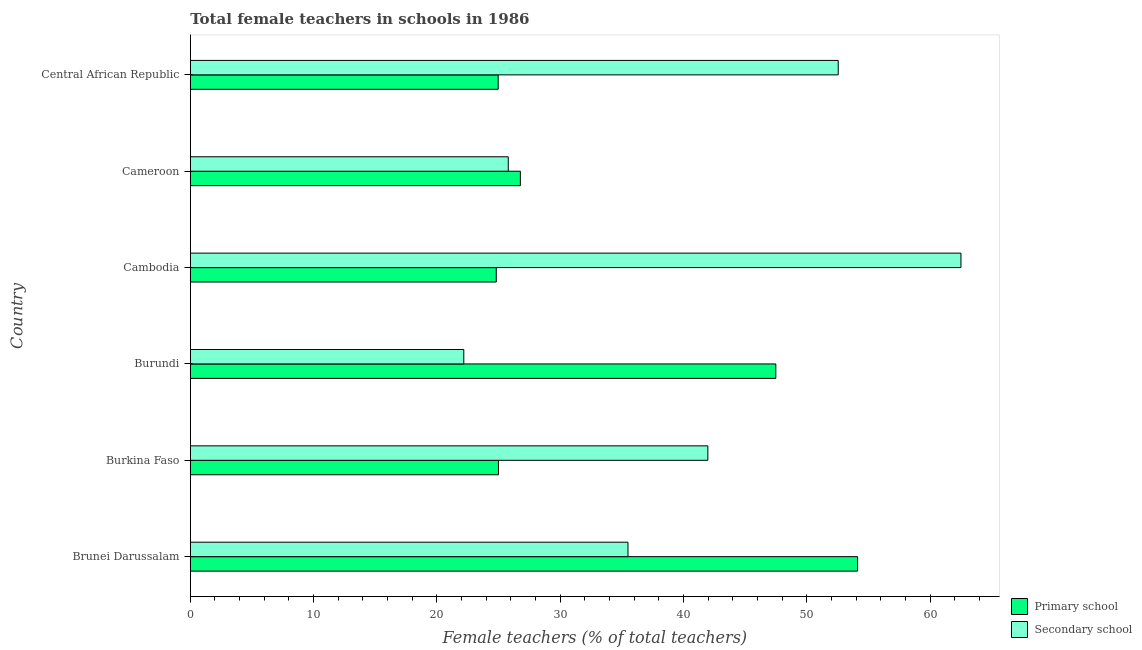How many groups of bars are there?
Give a very brief answer. 6. Are the number of bars on each tick of the Y-axis equal?
Ensure brevity in your answer.  Yes. How many bars are there on the 6th tick from the top?
Provide a succinct answer. 2. How many bars are there on the 2nd tick from the bottom?
Offer a very short reply. 2. What is the label of the 6th group of bars from the top?
Your answer should be compact. Brunei Darussalam. In how many cases, is the number of bars for a given country not equal to the number of legend labels?
Give a very brief answer. 0. What is the percentage of female teachers in primary schools in Brunei Darussalam?
Give a very brief answer. 54.11. Across all countries, what is the maximum percentage of female teachers in primary schools?
Offer a terse response. 54.11. Across all countries, what is the minimum percentage of female teachers in primary schools?
Offer a terse response. 24.81. In which country was the percentage of female teachers in secondary schools maximum?
Ensure brevity in your answer.  Cambodia. In which country was the percentage of female teachers in primary schools minimum?
Offer a terse response. Cambodia. What is the total percentage of female teachers in secondary schools in the graph?
Keep it short and to the point. 240.46. What is the difference between the percentage of female teachers in primary schools in Brunei Darussalam and that in Burundi?
Provide a succinct answer. 6.63. What is the difference between the percentage of female teachers in primary schools in Cameroon and the percentage of female teachers in secondary schools in Burkina Faso?
Provide a short and direct response. -15.2. What is the average percentage of female teachers in primary schools per country?
Give a very brief answer. 33.85. What is the difference between the percentage of female teachers in primary schools and percentage of female teachers in secondary schools in Central African Republic?
Keep it short and to the point. -27.57. What is the ratio of the percentage of female teachers in primary schools in Burundi to that in Cambodia?
Your answer should be very brief. 1.91. Is the percentage of female teachers in secondary schools in Brunei Darussalam less than that in Burundi?
Your answer should be compact. No. Is the difference between the percentage of female teachers in primary schools in Cambodia and Central African Republic greater than the difference between the percentage of female teachers in secondary schools in Cambodia and Central African Republic?
Provide a short and direct response. No. What is the difference between the highest and the second highest percentage of female teachers in secondary schools?
Offer a terse response. 9.95. What is the difference between the highest and the lowest percentage of female teachers in primary schools?
Your response must be concise. 29.3. In how many countries, is the percentage of female teachers in primary schools greater than the average percentage of female teachers in primary schools taken over all countries?
Keep it short and to the point. 2. Is the sum of the percentage of female teachers in secondary schools in Burkina Faso and Central African Republic greater than the maximum percentage of female teachers in primary schools across all countries?
Make the answer very short. Yes. What does the 1st bar from the top in Cameroon represents?
Offer a very short reply. Secondary school. What does the 1st bar from the bottom in Central African Republic represents?
Give a very brief answer. Primary school. How many bars are there?
Give a very brief answer. 12. Are all the bars in the graph horizontal?
Provide a succinct answer. Yes. What is the difference between two consecutive major ticks on the X-axis?
Keep it short and to the point. 10. Are the values on the major ticks of X-axis written in scientific E-notation?
Keep it short and to the point. No. Does the graph contain any zero values?
Offer a terse response. No. Where does the legend appear in the graph?
Ensure brevity in your answer.  Bottom right. How many legend labels are there?
Your answer should be compact. 2. What is the title of the graph?
Give a very brief answer. Total female teachers in schools in 1986. Does "Tetanus" appear as one of the legend labels in the graph?
Offer a very short reply. No. What is the label or title of the X-axis?
Ensure brevity in your answer.  Female teachers (% of total teachers). What is the label or title of the Y-axis?
Your answer should be very brief. Country. What is the Female teachers (% of total teachers) of Primary school in Brunei Darussalam?
Your response must be concise. 54.11. What is the Female teachers (% of total teachers) of Secondary school in Brunei Darussalam?
Make the answer very short. 35.49. What is the Female teachers (% of total teachers) of Primary school in Burkina Faso?
Your response must be concise. 24.99. What is the Female teachers (% of total teachers) in Secondary school in Burkina Faso?
Make the answer very short. 41.97. What is the Female teachers (% of total teachers) of Primary school in Burundi?
Provide a short and direct response. 47.48. What is the Female teachers (% of total teachers) in Secondary school in Burundi?
Offer a terse response. 22.18. What is the Female teachers (% of total teachers) of Primary school in Cambodia?
Ensure brevity in your answer.  24.81. What is the Female teachers (% of total teachers) in Secondary school in Cambodia?
Offer a terse response. 62.49. What is the Female teachers (% of total teachers) in Primary school in Cameroon?
Offer a very short reply. 26.77. What is the Female teachers (% of total teachers) in Secondary school in Cameroon?
Offer a terse response. 25.78. What is the Female teachers (% of total teachers) in Primary school in Central African Republic?
Your response must be concise. 24.97. What is the Female teachers (% of total teachers) of Secondary school in Central African Republic?
Your response must be concise. 52.54. Across all countries, what is the maximum Female teachers (% of total teachers) of Primary school?
Keep it short and to the point. 54.11. Across all countries, what is the maximum Female teachers (% of total teachers) of Secondary school?
Make the answer very short. 62.49. Across all countries, what is the minimum Female teachers (% of total teachers) in Primary school?
Provide a short and direct response. 24.81. Across all countries, what is the minimum Female teachers (% of total teachers) in Secondary school?
Your answer should be very brief. 22.18. What is the total Female teachers (% of total teachers) of Primary school in the graph?
Your response must be concise. 203.13. What is the total Female teachers (% of total teachers) in Secondary school in the graph?
Offer a very short reply. 240.46. What is the difference between the Female teachers (% of total teachers) in Primary school in Brunei Darussalam and that in Burkina Faso?
Keep it short and to the point. 29.12. What is the difference between the Female teachers (% of total teachers) of Secondary school in Brunei Darussalam and that in Burkina Faso?
Offer a very short reply. -6.48. What is the difference between the Female teachers (% of total teachers) of Primary school in Brunei Darussalam and that in Burundi?
Provide a succinct answer. 6.63. What is the difference between the Female teachers (% of total teachers) in Secondary school in Brunei Darussalam and that in Burundi?
Ensure brevity in your answer.  13.31. What is the difference between the Female teachers (% of total teachers) of Primary school in Brunei Darussalam and that in Cambodia?
Your response must be concise. 29.3. What is the difference between the Female teachers (% of total teachers) of Secondary school in Brunei Darussalam and that in Cambodia?
Offer a terse response. -27. What is the difference between the Female teachers (% of total teachers) in Primary school in Brunei Darussalam and that in Cameroon?
Make the answer very short. 27.35. What is the difference between the Female teachers (% of total teachers) of Secondary school in Brunei Darussalam and that in Cameroon?
Give a very brief answer. 9.71. What is the difference between the Female teachers (% of total teachers) in Primary school in Brunei Darussalam and that in Central African Republic?
Provide a succinct answer. 29.14. What is the difference between the Female teachers (% of total teachers) in Secondary school in Brunei Darussalam and that in Central African Republic?
Make the answer very short. -17.05. What is the difference between the Female teachers (% of total teachers) of Primary school in Burkina Faso and that in Burundi?
Offer a very short reply. -22.49. What is the difference between the Female teachers (% of total teachers) of Secondary school in Burkina Faso and that in Burundi?
Give a very brief answer. 19.79. What is the difference between the Female teachers (% of total teachers) in Primary school in Burkina Faso and that in Cambodia?
Give a very brief answer. 0.18. What is the difference between the Female teachers (% of total teachers) in Secondary school in Burkina Faso and that in Cambodia?
Offer a very short reply. -20.52. What is the difference between the Female teachers (% of total teachers) in Primary school in Burkina Faso and that in Cameroon?
Offer a terse response. -1.78. What is the difference between the Female teachers (% of total teachers) of Secondary school in Burkina Faso and that in Cameroon?
Keep it short and to the point. 16.19. What is the difference between the Female teachers (% of total teachers) in Primary school in Burkina Faso and that in Central African Republic?
Give a very brief answer. 0.02. What is the difference between the Female teachers (% of total teachers) in Secondary school in Burkina Faso and that in Central African Republic?
Make the answer very short. -10.57. What is the difference between the Female teachers (% of total teachers) in Primary school in Burundi and that in Cambodia?
Make the answer very short. 22.67. What is the difference between the Female teachers (% of total teachers) in Secondary school in Burundi and that in Cambodia?
Offer a terse response. -40.32. What is the difference between the Female teachers (% of total teachers) of Primary school in Burundi and that in Cameroon?
Provide a succinct answer. 20.71. What is the difference between the Female teachers (% of total teachers) in Secondary school in Burundi and that in Cameroon?
Your answer should be very brief. -3.6. What is the difference between the Female teachers (% of total teachers) of Primary school in Burundi and that in Central African Republic?
Offer a very short reply. 22.51. What is the difference between the Female teachers (% of total teachers) in Secondary school in Burundi and that in Central African Republic?
Your response must be concise. -30.36. What is the difference between the Female teachers (% of total teachers) in Primary school in Cambodia and that in Cameroon?
Your response must be concise. -1.95. What is the difference between the Female teachers (% of total teachers) of Secondary school in Cambodia and that in Cameroon?
Provide a succinct answer. 36.71. What is the difference between the Female teachers (% of total teachers) of Primary school in Cambodia and that in Central African Republic?
Offer a terse response. -0.16. What is the difference between the Female teachers (% of total teachers) in Secondary school in Cambodia and that in Central African Republic?
Give a very brief answer. 9.95. What is the difference between the Female teachers (% of total teachers) of Primary school in Cameroon and that in Central African Republic?
Your answer should be compact. 1.8. What is the difference between the Female teachers (% of total teachers) in Secondary school in Cameroon and that in Central African Republic?
Offer a very short reply. -26.76. What is the difference between the Female teachers (% of total teachers) in Primary school in Brunei Darussalam and the Female teachers (% of total teachers) in Secondary school in Burkina Faso?
Your answer should be very brief. 12.14. What is the difference between the Female teachers (% of total teachers) in Primary school in Brunei Darussalam and the Female teachers (% of total teachers) in Secondary school in Burundi?
Your response must be concise. 31.93. What is the difference between the Female teachers (% of total teachers) of Primary school in Brunei Darussalam and the Female teachers (% of total teachers) of Secondary school in Cambodia?
Offer a terse response. -8.38. What is the difference between the Female teachers (% of total teachers) in Primary school in Brunei Darussalam and the Female teachers (% of total teachers) in Secondary school in Cameroon?
Offer a very short reply. 28.33. What is the difference between the Female teachers (% of total teachers) of Primary school in Brunei Darussalam and the Female teachers (% of total teachers) of Secondary school in Central African Republic?
Your response must be concise. 1.57. What is the difference between the Female teachers (% of total teachers) of Primary school in Burkina Faso and the Female teachers (% of total teachers) of Secondary school in Burundi?
Your response must be concise. 2.81. What is the difference between the Female teachers (% of total teachers) of Primary school in Burkina Faso and the Female teachers (% of total teachers) of Secondary school in Cambodia?
Your answer should be compact. -37.51. What is the difference between the Female teachers (% of total teachers) of Primary school in Burkina Faso and the Female teachers (% of total teachers) of Secondary school in Cameroon?
Your response must be concise. -0.8. What is the difference between the Female teachers (% of total teachers) in Primary school in Burkina Faso and the Female teachers (% of total teachers) in Secondary school in Central African Republic?
Provide a short and direct response. -27.55. What is the difference between the Female teachers (% of total teachers) in Primary school in Burundi and the Female teachers (% of total teachers) in Secondary school in Cambodia?
Your response must be concise. -15.01. What is the difference between the Female teachers (% of total teachers) in Primary school in Burundi and the Female teachers (% of total teachers) in Secondary school in Cameroon?
Your response must be concise. 21.7. What is the difference between the Female teachers (% of total teachers) of Primary school in Burundi and the Female teachers (% of total teachers) of Secondary school in Central African Republic?
Provide a succinct answer. -5.06. What is the difference between the Female teachers (% of total teachers) in Primary school in Cambodia and the Female teachers (% of total teachers) in Secondary school in Cameroon?
Provide a short and direct response. -0.97. What is the difference between the Female teachers (% of total teachers) in Primary school in Cambodia and the Female teachers (% of total teachers) in Secondary school in Central African Republic?
Offer a terse response. -27.73. What is the difference between the Female teachers (% of total teachers) in Primary school in Cameroon and the Female teachers (% of total teachers) in Secondary school in Central African Republic?
Offer a terse response. -25.78. What is the average Female teachers (% of total teachers) in Primary school per country?
Your answer should be very brief. 33.85. What is the average Female teachers (% of total teachers) in Secondary school per country?
Offer a very short reply. 40.08. What is the difference between the Female teachers (% of total teachers) of Primary school and Female teachers (% of total teachers) of Secondary school in Brunei Darussalam?
Keep it short and to the point. 18.62. What is the difference between the Female teachers (% of total teachers) in Primary school and Female teachers (% of total teachers) in Secondary school in Burkina Faso?
Offer a terse response. -16.98. What is the difference between the Female teachers (% of total teachers) in Primary school and Female teachers (% of total teachers) in Secondary school in Burundi?
Your response must be concise. 25.3. What is the difference between the Female teachers (% of total teachers) in Primary school and Female teachers (% of total teachers) in Secondary school in Cambodia?
Provide a short and direct response. -37.68. What is the difference between the Female teachers (% of total teachers) in Primary school and Female teachers (% of total teachers) in Secondary school in Cameroon?
Your response must be concise. 0.98. What is the difference between the Female teachers (% of total teachers) of Primary school and Female teachers (% of total teachers) of Secondary school in Central African Republic?
Offer a very short reply. -27.57. What is the ratio of the Female teachers (% of total teachers) of Primary school in Brunei Darussalam to that in Burkina Faso?
Provide a succinct answer. 2.17. What is the ratio of the Female teachers (% of total teachers) of Secondary school in Brunei Darussalam to that in Burkina Faso?
Keep it short and to the point. 0.85. What is the ratio of the Female teachers (% of total teachers) in Primary school in Brunei Darussalam to that in Burundi?
Provide a succinct answer. 1.14. What is the ratio of the Female teachers (% of total teachers) in Secondary school in Brunei Darussalam to that in Burundi?
Keep it short and to the point. 1.6. What is the ratio of the Female teachers (% of total teachers) of Primary school in Brunei Darussalam to that in Cambodia?
Provide a short and direct response. 2.18. What is the ratio of the Female teachers (% of total teachers) of Secondary school in Brunei Darussalam to that in Cambodia?
Offer a very short reply. 0.57. What is the ratio of the Female teachers (% of total teachers) of Primary school in Brunei Darussalam to that in Cameroon?
Provide a succinct answer. 2.02. What is the ratio of the Female teachers (% of total teachers) of Secondary school in Brunei Darussalam to that in Cameroon?
Offer a very short reply. 1.38. What is the ratio of the Female teachers (% of total teachers) of Primary school in Brunei Darussalam to that in Central African Republic?
Give a very brief answer. 2.17. What is the ratio of the Female teachers (% of total teachers) of Secondary school in Brunei Darussalam to that in Central African Republic?
Offer a terse response. 0.68. What is the ratio of the Female teachers (% of total teachers) in Primary school in Burkina Faso to that in Burundi?
Ensure brevity in your answer.  0.53. What is the ratio of the Female teachers (% of total teachers) in Secondary school in Burkina Faso to that in Burundi?
Your answer should be very brief. 1.89. What is the ratio of the Female teachers (% of total teachers) in Primary school in Burkina Faso to that in Cambodia?
Your response must be concise. 1.01. What is the ratio of the Female teachers (% of total teachers) in Secondary school in Burkina Faso to that in Cambodia?
Make the answer very short. 0.67. What is the ratio of the Female teachers (% of total teachers) of Primary school in Burkina Faso to that in Cameroon?
Provide a succinct answer. 0.93. What is the ratio of the Female teachers (% of total teachers) in Secondary school in Burkina Faso to that in Cameroon?
Your answer should be very brief. 1.63. What is the ratio of the Female teachers (% of total teachers) in Secondary school in Burkina Faso to that in Central African Republic?
Ensure brevity in your answer.  0.8. What is the ratio of the Female teachers (% of total teachers) in Primary school in Burundi to that in Cambodia?
Make the answer very short. 1.91. What is the ratio of the Female teachers (% of total teachers) of Secondary school in Burundi to that in Cambodia?
Offer a very short reply. 0.35. What is the ratio of the Female teachers (% of total teachers) in Primary school in Burundi to that in Cameroon?
Your answer should be very brief. 1.77. What is the ratio of the Female teachers (% of total teachers) of Secondary school in Burundi to that in Cameroon?
Offer a very short reply. 0.86. What is the ratio of the Female teachers (% of total teachers) of Primary school in Burundi to that in Central African Republic?
Give a very brief answer. 1.9. What is the ratio of the Female teachers (% of total teachers) of Secondary school in Burundi to that in Central African Republic?
Offer a very short reply. 0.42. What is the ratio of the Female teachers (% of total teachers) in Primary school in Cambodia to that in Cameroon?
Offer a terse response. 0.93. What is the ratio of the Female teachers (% of total teachers) of Secondary school in Cambodia to that in Cameroon?
Provide a short and direct response. 2.42. What is the ratio of the Female teachers (% of total teachers) in Primary school in Cambodia to that in Central African Republic?
Offer a terse response. 0.99. What is the ratio of the Female teachers (% of total teachers) in Secondary school in Cambodia to that in Central African Republic?
Provide a short and direct response. 1.19. What is the ratio of the Female teachers (% of total teachers) in Primary school in Cameroon to that in Central African Republic?
Offer a very short reply. 1.07. What is the ratio of the Female teachers (% of total teachers) in Secondary school in Cameroon to that in Central African Republic?
Ensure brevity in your answer.  0.49. What is the difference between the highest and the second highest Female teachers (% of total teachers) in Primary school?
Ensure brevity in your answer.  6.63. What is the difference between the highest and the second highest Female teachers (% of total teachers) of Secondary school?
Offer a very short reply. 9.95. What is the difference between the highest and the lowest Female teachers (% of total teachers) in Primary school?
Provide a short and direct response. 29.3. What is the difference between the highest and the lowest Female teachers (% of total teachers) in Secondary school?
Keep it short and to the point. 40.32. 